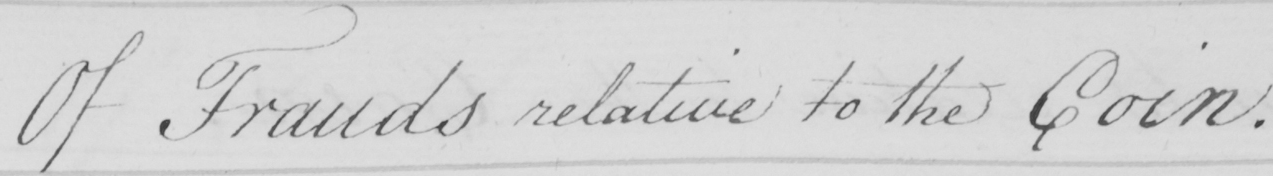What text is written in this handwritten line? Of Frauds relative to the Coin . 